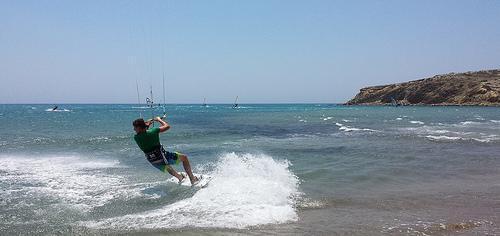How many people are surfing?
Give a very brief answer. 1. 